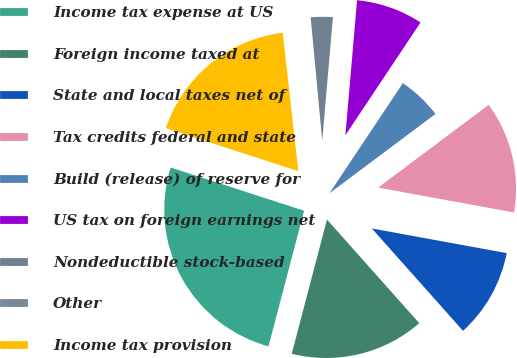Convert chart. <chart><loc_0><loc_0><loc_500><loc_500><pie_chart><fcel>Income tax expense at US<fcel>Foreign income taxed at<fcel>State and local taxes net of<fcel>Tax credits federal and state<fcel>Build (release) of reserve for<fcel>US tax on foreign earnings net<fcel>Nondeductible stock-based<fcel>Other<fcel>Income tax provision<nl><fcel>25.9%<fcel>15.66%<fcel>10.54%<fcel>13.1%<fcel>5.42%<fcel>7.98%<fcel>2.86%<fcel>0.3%<fcel>18.22%<nl></chart> 